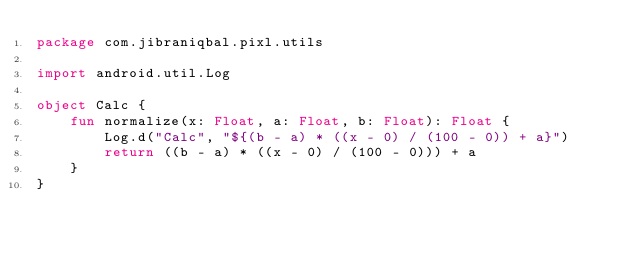Convert code to text. <code><loc_0><loc_0><loc_500><loc_500><_Kotlin_>package com.jibraniqbal.pixl.utils

import android.util.Log

object Calc {
    fun normalize(x: Float, a: Float, b: Float): Float {
        Log.d("Calc", "${(b - a) * ((x - 0) / (100 - 0)) + a}")
        return ((b - a) * ((x - 0) / (100 - 0))) + a
    }
}</code> 